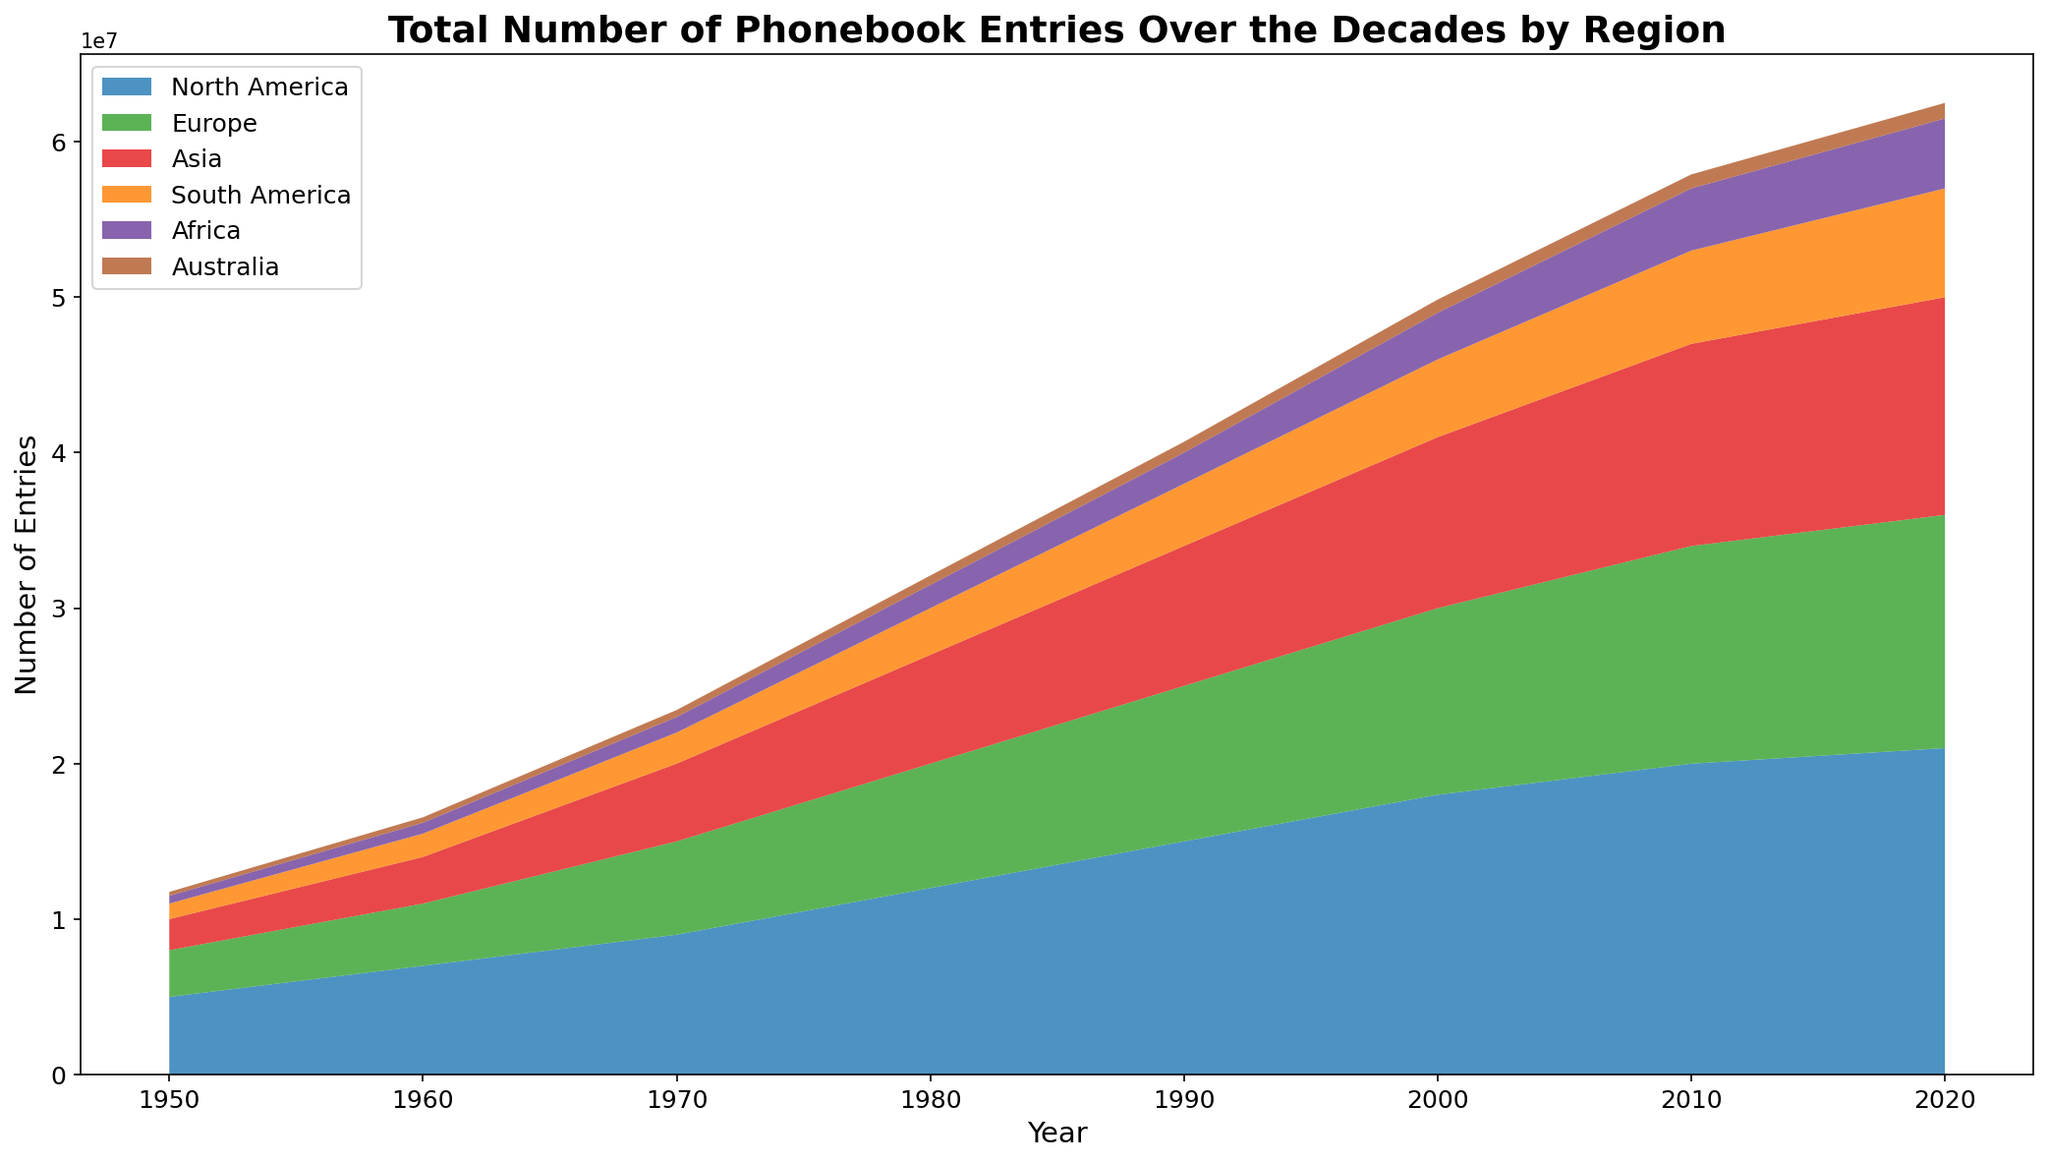What year did North America have the highest number of phonebook entries? The peak value for North America is seen at the rightmost point of the North America section, which occurs in 2020.
Answer: 2020 Which region had the smallest increase in phonebook entries from 1950 to 2020? Calculate the difference in values from 1950 to 2020 for each region and identify the smallest increase. North America: 21000000 - 5000000 = 16000000, Europe: 15000000 - 3000000 = 12000000, Asia: 14000000 - 2000000 = 12000000, South America: 7000000 - 1000000 = 6000000, Africa: 4500000 - 500000 = 4000000, Australia: 1000000 - 250000 = 750000. The smallest increase is for Australia.
Answer: Australia How many entries did Europe have in 1980 compared to Asia's entries in 1950? From the chart, in 1980 Europe had 8000000 entries and Asia had 2000000 entries in 1950.
Answer: Europe: 8000000, Asia: 2000000 Which two regions had the closest number of entries in 2020? Compare the values for all regions in 2020 and find the smallest difference. North America: 21000000, Europe: 15000000, Asia: 14000000, South America: 7000000, Africa: 4500000, Australia: 1000000. The closest values are Europe and Asia, with a difference of 15000000 - 14000000 = 1000000.
Answer: Europe and Asia What is the total number of phonebook entries across all regions in 2000? Sum the values for each region in 2000: North America 18000000, Europe 12000000, Asia 11000000, South America 5000000, Africa 3000000, Australia 850000. The total is 18000000 + 12000000 + 11000000 + 5000000 + 3000000 + 850000 = 49850000.
Answer: 49850000 In which decade did North America pass 10000000 phonebook entries? Look at the North America data trend. North America surpassed 10000000 entries between 1970 (9000000) and 1980 (12000000).
Answer: 1980 Which region had the largest phonebook entries growth rate between 1960 and 1970? Calculate the growth rate using the formula (1970 value - 1960 value) / 1960 value for each region. North America: (9000000 - 7000000) / 7000000 ≈ 0.286, Europe: (6000000 - 4000000) / 4000000 = 0.5, Asia: (5000000 - 3000000) / 3000000 ≈ 0.667, South America: (2000000 - 1500000) / 1500000 ≈ 0.333, Africa: (1000000 - 700000) / 700000 ≈ 0.429, Australia: (450000 - 350000) / 350000 ≈ 0.286. Asia has the highest growth rate.
Answer: Asia What pattern can be observed in phonebook entries for Australia from 1950 to 2020? Observe the trend for Australia. Entries consistently grew over the decades: 250000, 350000, 450000, 600000, 700000, 850000, 900000, 1000000, showing steady but small increases.
Answer: Steady growth Which regions had over 10000000 entries by 2020? Check the 2020 values for each region. North America: 21000000, Europe: 15000000, Asia: 14000000, South America: 7000000, Africa: 4500000, Australia: 1000000. North America, Europe, and Asia had over 10000000 entries.
Answer: North America, Europe, Asia What is the combined number of entries for Africa and South America in 2010? Add the entries for Africa and South America in 2010: Africa 4000000 + South America 6000000 = 10000000.
Answer: 10000000 